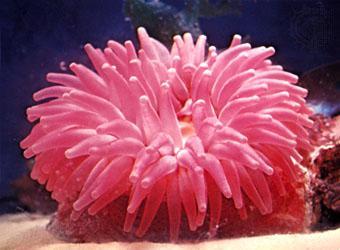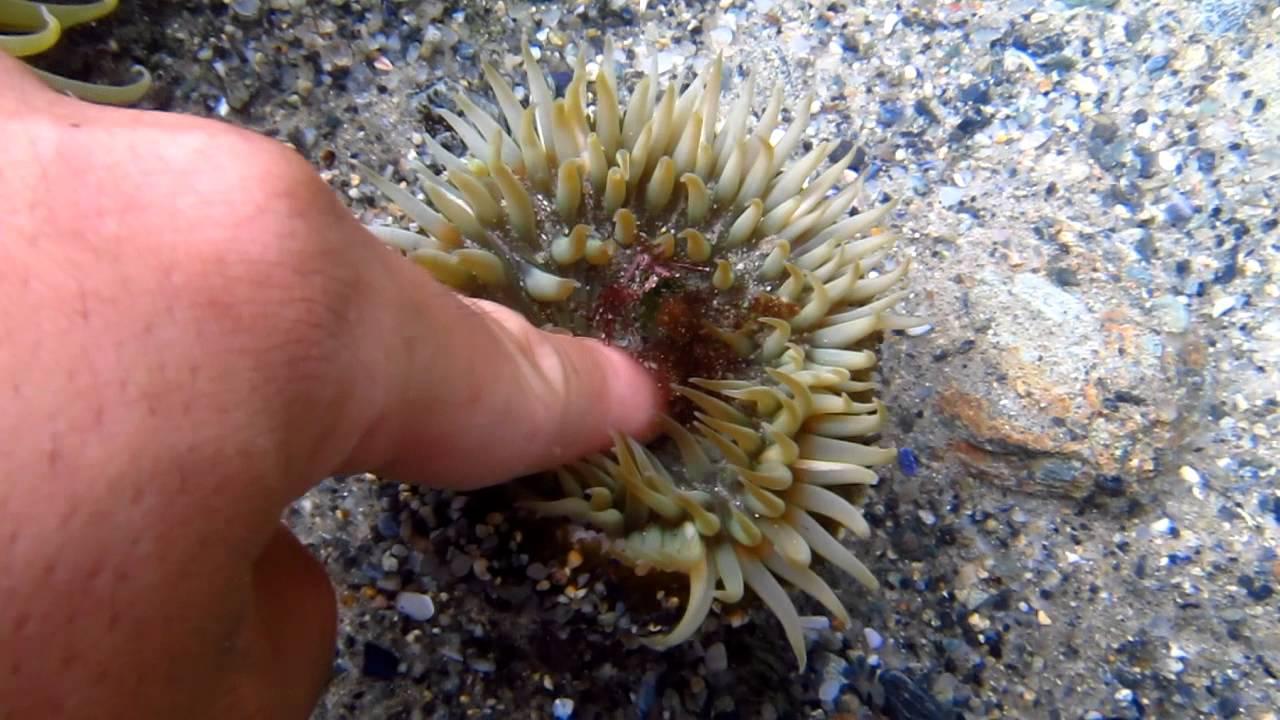The first image is the image on the left, the second image is the image on the right. Analyze the images presented: Is the assertion "Another creature is amongst the coral." valid? Answer yes or no. Yes. The first image is the image on the left, the second image is the image on the right. For the images shown, is this caption "An image shows a round pinkish anemone with monochrome, non-ombre tendrils." true? Answer yes or no. Yes. 